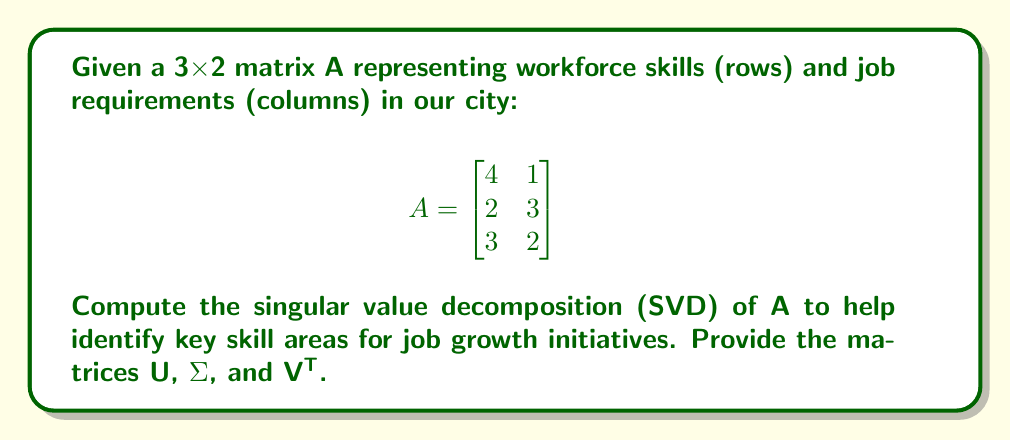Solve this math problem. To find the singular value decomposition A = UΣV^T, we follow these steps:

1) Calculate A^T A and AA^T:

   $$A^T A = \begin{bmatrix}
   4 & 2 & 3 \\
   1 & 3 & 2
   \end{bmatrix} \begin{bmatrix}
   4 & 1 \\
   2 & 3 \\
   3 & 2
   \end{bmatrix} = \begin{bmatrix}
   29 & 16 \\
   16 & 14
   \end{bmatrix}$$

   $$AA^T = \begin{bmatrix}
   4 & 1 \\
   2 & 3 \\
   3 & 2
   \end{bmatrix} \begin{bmatrix}
   4 & 2 & 3 \\
   1 & 3 & 2
   \end{bmatrix} = \begin{bmatrix}
   17 & 10 & 14 \\
   10 & 13 & 12 \\
   14 & 12 & 13
   \end{bmatrix}$$

2) Find eigenvalues of A^T A:
   $det(A^T A - λI) = \begin{vmatrix}
   29-λ & 16 \\
   16 & 14-λ
   \end{vmatrix} = (29-λ)(14-λ) - 256 = λ^2 - 43λ + 150 = 0$

   Solving this equation: λ₁ ≈ 40.81, λ₂ ≈ 2.19

3) Singular values are square roots of these eigenvalues:
   σ₁ ≈ √40.81 ≈ 6.39, σ₂ ≈ √2.19 ≈ 1.48

4) Find eigenvectors of A^T A for V:
   For λ₁ ≈ 40.81: $\begin{bmatrix}
   -11.81 & 16 \\
   16 & -26.81
   \end{bmatrix} \begin{bmatrix}
   x \\
   y
   \end{bmatrix} = \begin{bmatrix}
   0 \\
   0
   \end{bmatrix}$

   Solving, we get v₁ ≈ [0.82, 0.57]^T

   Similarly, for λ₂, we get v₂ ≈ [-0.57, 0.82]^T

5) Find eigenvectors of AA^T for U:
   We can use u₁ = Av₁/σ₁ and u₂ = Av₂/σ₂

   u₁ ≈ [0.59, 0.53, 0.61]^T
   u₂ ≈ [-0.36, 0.84, -0.40]^T

   The third column of U is the cross product of these two:
   u₃ ≈ [0.72, -0.11, -0.69]^T

6) Construct the matrices:

   $$U ≈ \begin{bmatrix}
   0.59 & -0.36 & 0.72 \\
   0.53 & 0.84 & -0.11 \\
   0.61 & -0.40 & -0.69
   \end{bmatrix}$$

   $$Σ ≈ \begin{bmatrix}
   6.39 & 0 \\
   0 & 1.48 \\
   0 & 0
   \end{bmatrix}$$

   $$V^T ≈ \begin{bmatrix}
   0.82 & 0.57 \\
   -0.57 & 0.82
   \end{bmatrix}$$
Answer: $$U ≈ \begin{bmatrix}
0.59 & -0.36 & 0.72 \\
0.53 & 0.84 & -0.11 \\
0.61 & -0.40 & -0.69
\end{bmatrix}, Σ ≈ \begin{bmatrix}
6.39 & 0 \\
0 & 1.48 \\
0 & 0
\end{bmatrix}, V^T ≈ \begin{bmatrix}
0.82 & 0.57 \\
-0.57 & 0.82
\end{bmatrix}$$ 